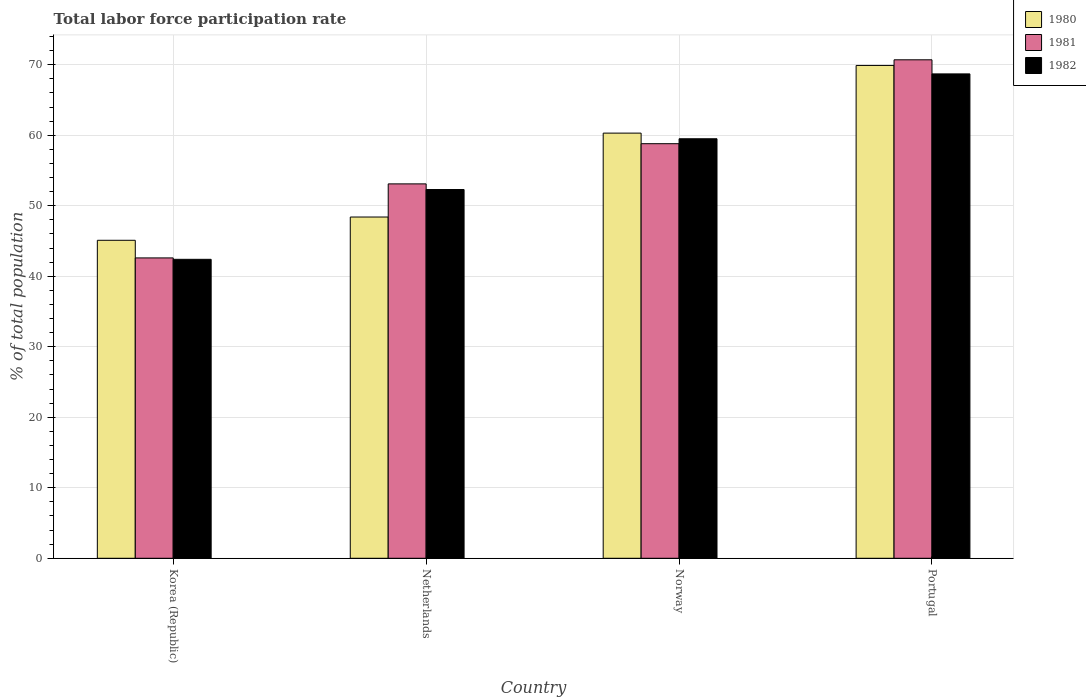Are the number of bars per tick equal to the number of legend labels?
Keep it short and to the point. Yes. How many bars are there on the 2nd tick from the left?
Give a very brief answer. 3. How many bars are there on the 2nd tick from the right?
Your answer should be compact. 3. What is the label of the 3rd group of bars from the left?
Give a very brief answer. Norway. What is the total labor force participation rate in 1980 in Netherlands?
Ensure brevity in your answer.  48.4. Across all countries, what is the maximum total labor force participation rate in 1981?
Offer a terse response. 70.7. Across all countries, what is the minimum total labor force participation rate in 1982?
Offer a very short reply. 42.4. In which country was the total labor force participation rate in 1982 maximum?
Ensure brevity in your answer.  Portugal. In which country was the total labor force participation rate in 1981 minimum?
Ensure brevity in your answer.  Korea (Republic). What is the total total labor force participation rate in 1980 in the graph?
Give a very brief answer. 223.7. What is the difference between the total labor force participation rate in 1982 in Korea (Republic) and that in Netherlands?
Provide a short and direct response. -9.9. What is the difference between the total labor force participation rate in 1982 in Netherlands and the total labor force participation rate in 1981 in Korea (Republic)?
Provide a succinct answer. 9.7. What is the average total labor force participation rate in 1980 per country?
Keep it short and to the point. 55.93. What is the difference between the total labor force participation rate of/in 1982 and total labor force participation rate of/in 1980 in Korea (Republic)?
Ensure brevity in your answer.  -2.7. What is the ratio of the total labor force participation rate in 1982 in Norway to that in Portugal?
Offer a very short reply. 0.87. What is the difference between the highest and the second highest total labor force participation rate in 1982?
Keep it short and to the point. -9.2. What is the difference between the highest and the lowest total labor force participation rate in 1980?
Offer a very short reply. 24.8. Is the sum of the total labor force participation rate in 1980 in Korea (Republic) and Portugal greater than the maximum total labor force participation rate in 1981 across all countries?
Give a very brief answer. Yes. What does the 1st bar from the right in Netherlands represents?
Your response must be concise. 1982. Is it the case that in every country, the sum of the total labor force participation rate in 1981 and total labor force participation rate in 1982 is greater than the total labor force participation rate in 1980?
Provide a succinct answer. Yes. How many bars are there?
Give a very brief answer. 12. Are all the bars in the graph horizontal?
Your answer should be very brief. No. Are the values on the major ticks of Y-axis written in scientific E-notation?
Your answer should be very brief. No. Does the graph contain any zero values?
Keep it short and to the point. No. Where does the legend appear in the graph?
Your response must be concise. Top right. How many legend labels are there?
Provide a succinct answer. 3. How are the legend labels stacked?
Your answer should be very brief. Vertical. What is the title of the graph?
Make the answer very short. Total labor force participation rate. Does "1997" appear as one of the legend labels in the graph?
Make the answer very short. No. What is the label or title of the Y-axis?
Provide a succinct answer. % of total population. What is the % of total population in 1980 in Korea (Republic)?
Keep it short and to the point. 45.1. What is the % of total population in 1981 in Korea (Republic)?
Offer a terse response. 42.6. What is the % of total population of 1982 in Korea (Republic)?
Give a very brief answer. 42.4. What is the % of total population of 1980 in Netherlands?
Offer a terse response. 48.4. What is the % of total population in 1981 in Netherlands?
Give a very brief answer. 53.1. What is the % of total population of 1982 in Netherlands?
Your answer should be compact. 52.3. What is the % of total population of 1980 in Norway?
Your answer should be compact. 60.3. What is the % of total population of 1981 in Norway?
Offer a very short reply. 58.8. What is the % of total population in 1982 in Norway?
Offer a terse response. 59.5. What is the % of total population of 1980 in Portugal?
Provide a short and direct response. 69.9. What is the % of total population in 1981 in Portugal?
Your answer should be compact. 70.7. What is the % of total population in 1982 in Portugal?
Provide a short and direct response. 68.7. Across all countries, what is the maximum % of total population of 1980?
Provide a succinct answer. 69.9. Across all countries, what is the maximum % of total population of 1981?
Make the answer very short. 70.7. Across all countries, what is the maximum % of total population in 1982?
Offer a terse response. 68.7. Across all countries, what is the minimum % of total population in 1980?
Give a very brief answer. 45.1. Across all countries, what is the minimum % of total population in 1981?
Ensure brevity in your answer.  42.6. Across all countries, what is the minimum % of total population in 1982?
Offer a terse response. 42.4. What is the total % of total population in 1980 in the graph?
Give a very brief answer. 223.7. What is the total % of total population of 1981 in the graph?
Provide a short and direct response. 225.2. What is the total % of total population of 1982 in the graph?
Your answer should be compact. 222.9. What is the difference between the % of total population of 1980 in Korea (Republic) and that in Netherlands?
Make the answer very short. -3.3. What is the difference between the % of total population of 1981 in Korea (Republic) and that in Netherlands?
Your answer should be very brief. -10.5. What is the difference between the % of total population in 1982 in Korea (Republic) and that in Netherlands?
Offer a very short reply. -9.9. What is the difference between the % of total population in 1980 in Korea (Republic) and that in Norway?
Provide a succinct answer. -15.2. What is the difference between the % of total population of 1981 in Korea (Republic) and that in Norway?
Provide a short and direct response. -16.2. What is the difference between the % of total population of 1982 in Korea (Republic) and that in Norway?
Your answer should be compact. -17.1. What is the difference between the % of total population in 1980 in Korea (Republic) and that in Portugal?
Keep it short and to the point. -24.8. What is the difference between the % of total population in 1981 in Korea (Republic) and that in Portugal?
Provide a short and direct response. -28.1. What is the difference between the % of total population in 1982 in Korea (Republic) and that in Portugal?
Make the answer very short. -26.3. What is the difference between the % of total population of 1981 in Netherlands and that in Norway?
Offer a terse response. -5.7. What is the difference between the % of total population in 1982 in Netherlands and that in Norway?
Provide a succinct answer. -7.2. What is the difference between the % of total population of 1980 in Netherlands and that in Portugal?
Provide a short and direct response. -21.5. What is the difference between the % of total population in 1981 in Netherlands and that in Portugal?
Your answer should be compact. -17.6. What is the difference between the % of total population of 1982 in Netherlands and that in Portugal?
Provide a short and direct response. -16.4. What is the difference between the % of total population in 1980 in Norway and that in Portugal?
Offer a very short reply. -9.6. What is the difference between the % of total population in 1981 in Norway and that in Portugal?
Ensure brevity in your answer.  -11.9. What is the difference between the % of total population of 1982 in Norway and that in Portugal?
Keep it short and to the point. -9.2. What is the difference between the % of total population in 1981 in Korea (Republic) and the % of total population in 1982 in Netherlands?
Provide a short and direct response. -9.7. What is the difference between the % of total population of 1980 in Korea (Republic) and the % of total population of 1981 in Norway?
Your answer should be very brief. -13.7. What is the difference between the % of total population in 1980 in Korea (Republic) and the % of total population in 1982 in Norway?
Give a very brief answer. -14.4. What is the difference between the % of total population of 1981 in Korea (Republic) and the % of total population of 1982 in Norway?
Offer a terse response. -16.9. What is the difference between the % of total population in 1980 in Korea (Republic) and the % of total population in 1981 in Portugal?
Offer a terse response. -25.6. What is the difference between the % of total population in 1980 in Korea (Republic) and the % of total population in 1982 in Portugal?
Make the answer very short. -23.6. What is the difference between the % of total population of 1981 in Korea (Republic) and the % of total population of 1982 in Portugal?
Provide a short and direct response. -26.1. What is the difference between the % of total population of 1980 in Netherlands and the % of total population of 1981 in Norway?
Offer a very short reply. -10.4. What is the difference between the % of total population in 1980 in Netherlands and the % of total population in 1982 in Norway?
Provide a succinct answer. -11.1. What is the difference between the % of total population of 1980 in Netherlands and the % of total population of 1981 in Portugal?
Your answer should be compact. -22.3. What is the difference between the % of total population of 1980 in Netherlands and the % of total population of 1982 in Portugal?
Your response must be concise. -20.3. What is the difference between the % of total population of 1981 in Netherlands and the % of total population of 1982 in Portugal?
Ensure brevity in your answer.  -15.6. What is the difference between the % of total population in 1980 in Norway and the % of total population in 1981 in Portugal?
Your response must be concise. -10.4. What is the difference between the % of total population of 1981 in Norway and the % of total population of 1982 in Portugal?
Your answer should be compact. -9.9. What is the average % of total population in 1980 per country?
Ensure brevity in your answer.  55.92. What is the average % of total population in 1981 per country?
Your answer should be very brief. 56.3. What is the average % of total population in 1982 per country?
Make the answer very short. 55.73. What is the difference between the % of total population in 1980 and % of total population in 1982 in Korea (Republic)?
Offer a very short reply. 2.7. What is the difference between the % of total population of 1980 and % of total population of 1981 in Netherlands?
Offer a terse response. -4.7. What is the difference between the % of total population in 1981 and % of total population in 1982 in Netherlands?
Ensure brevity in your answer.  0.8. What is the difference between the % of total population in 1980 and % of total population in 1981 in Norway?
Provide a short and direct response. 1.5. What is the difference between the % of total population of 1980 and % of total population of 1982 in Norway?
Ensure brevity in your answer.  0.8. What is the difference between the % of total population of 1980 and % of total population of 1981 in Portugal?
Your answer should be compact. -0.8. What is the ratio of the % of total population of 1980 in Korea (Republic) to that in Netherlands?
Keep it short and to the point. 0.93. What is the ratio of the % of total population of 1981 in Korea (Republic) to that in Netherlands?
Provide a succinct answer. 0.8. What is the ratio of the % of total population in 1982 in Korea (Republic) to that in Netherlands?
Provide a short and direct response. 0.81. What is the ratio of the % of total population of 1980 in Korea (Republic) to that in Norway?
Make the answer very short. 0.75. What is the ratio of the % of total population of 1981 in Korea (Republic) to that in Norway?
Ensure brevity in your answer.  0.72. What is the ratio of the % of total population of 1982 in Korea (Republic) to that in Norway?
Keep it short and to the point. 0.71. What is the ratio of the % of total population of 1980 in Korea (Republic) to that in Portugal?
Keep it short and to the point. 0.65. What is the ratio of the % of total population in 1981 in Korea (Republic) to that in Portugal?
Ensure brevity in your answer.  0.6. What is the ratio of the % of total population in 1982 in Korea (Republic) to that in Portugal?
Your answer should be compact. 0.62. What is the ratio of the % of total population of 1980 in Netherlands to that in Norway?
Your answer should be compact. 0.8. What is the ratio of the % of total population of 1981 in Netherlands to that in Norway?
Your answer should be very brief. 0.9. What is the ratio of the % of total population of 1982 in Netherlands to that in Norway?
Your response must be concise. 0.88. What is the ratio of the % of total population in 1980 in Netherlands to that in Portugal?
Make the answer very short. 0.69. What is the ratio of the % of total population in 1981 in Netherlands to that in Portugal?
Offer a terse response. 0.75. What is the ratio of the % of total population in 1982 in Netherlands to that in Portugal?
Your answer should be very brief. 0.76. What is the ratio of the % of total population of 1980 in Norway to that in Portugal?
Your answer should be compact. 0.86. What is the ratio of the % of total population in 1981 in Norway to that in Portugal?
Your answer should be compact. 0.83. What is the ratio of the % of total population of 1982 in Norway to that in Portugal?
Your answer should be very brief. 0.87. What is the difference between the highest and the second highest % of total population of 1981?
Keep it short and to the point. 11.9. What is the difference between the highest and the second highest % of total population of 1982?
Offer a terse response. 9.2. What is the difference between the highest and the lowest % of total population in 1980?
Provide a succinct answer. 24.8. What is the difference between the highest and the lowest % of total population of 1981?
Your answer should be compact. 28.1. What is the difference between the highest and the lowest % of total population of 1982?
Provide a short and direct response. 26.3. 